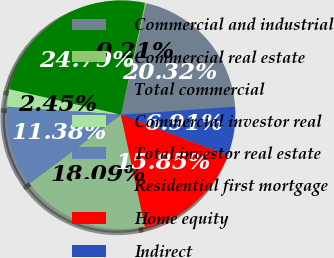Convert chart to OTSL. <chart><loc_0><loc_0><loc_500><loc_500><pie_chart><fcel>Commercial and industrial<fcel>Commercial real estate<fcel>Total commercial<fcel>Commercial investor real<fcel>Total investor real estate<fcel>Residential first mortgage<fcel>Home equity<fcel>Indirect<nl><fcel>20.32%<fcel>0.21%<fcel>24.79%<fcel>2.45%<fcel>11.38%<fcel>18.09%<fcel>15.85%<fcel>6.91%<nl></chart> 